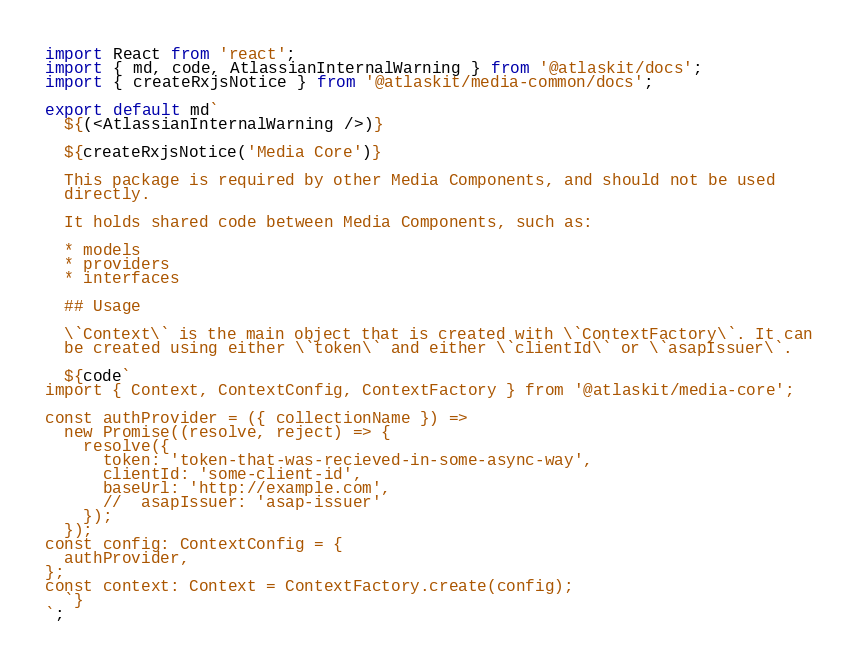<code> <loc_0><loc_0><loc_500><loc_500><_TypeScript_>import React from 'react';
import { md, code, AtlassianInternalWarning } from '@atlaskit/docs';
import { createRxjsNotice } from '@atlaskit/media-common/docs';

export default md`
  ${(<AtlassianInternalWarning />)}

  ${createRxjsNotice('Media Core')}

  This package is required by other Media Components, and should not be used
  directly.

  It holds shared code between Media Components, such as:

  * models
  * providers
  * interfaces

  ## Usage

  \`Context\` is the main object that is created with \`ContextFactory\`. It can
  be created using either \`token\` and either \`clientId\` or \`asapIssuer\`.

  ${code`
import { Context, ContextConfig, ContextFactory } from '@atlaskit/media-core';

const authProvider = ({ collectionName }) =>
  new Promise((resolve, reject) => {
    resolve({
      token: 'token-that-was-recieved-in-some-async-way',
      clientId: 'some-client-id',
      baseUrl: 'http://example.com',
      //  asapIssuer: 'asap-issuer'
    });
  });
const config: ContextConfig = {
  authProvider,
};
const context: Context = ContextFactory.create(config);
  `}
`;
</code> 